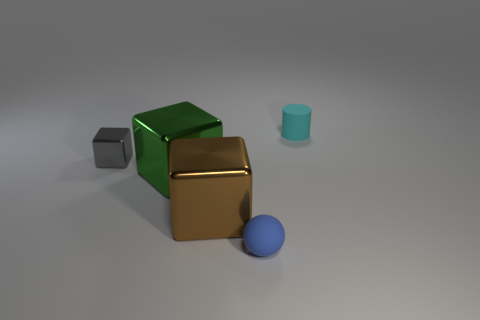What materials are the objects made of? The objects in the image seem to have different finishes: the cube is matte, the sphere has a slightly reflective surface, and the cylinder appears semi-glossy. 